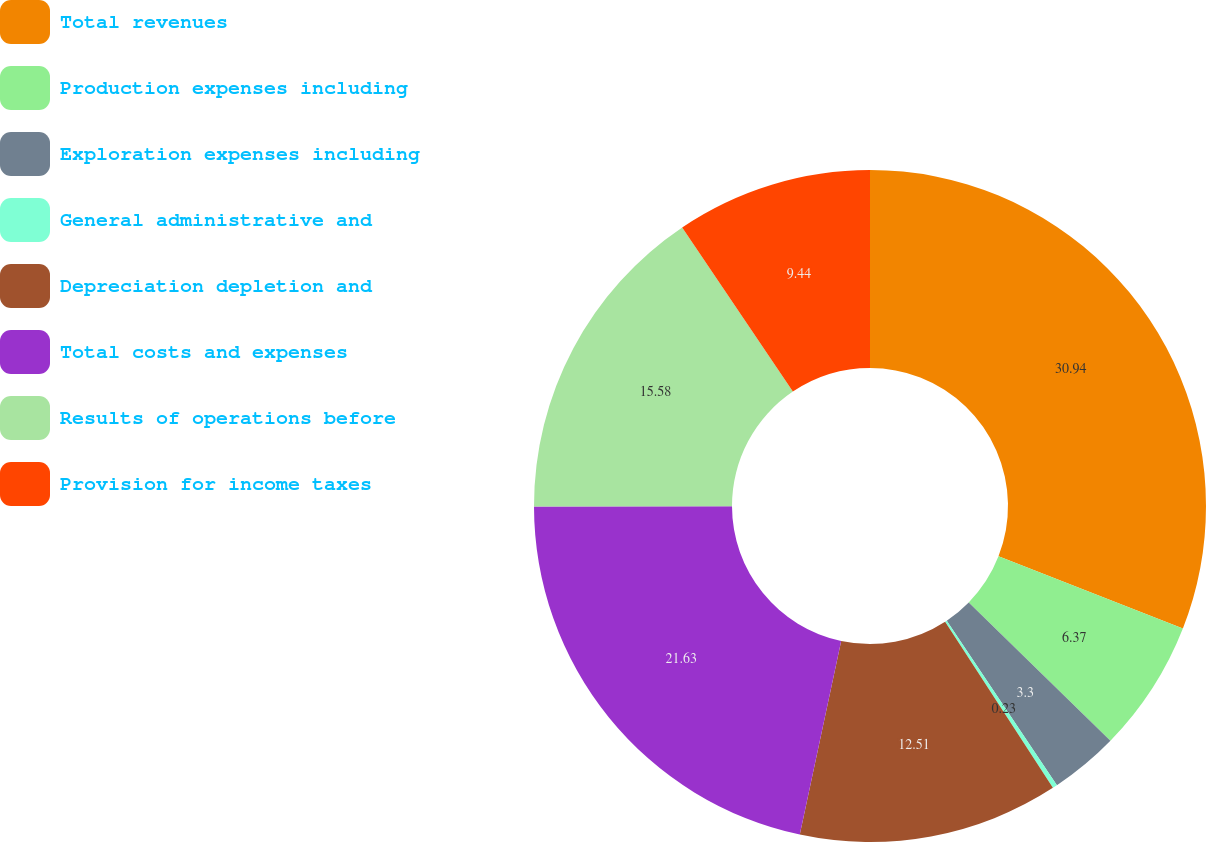Convert chart to OTSL. <chart><loc_0><loc_0><loc_500><loc_500><pie_chart><fcel>Total revenues<fcel>Production expenses including<fcel>Exploration expenses including<fcel>General administrative and<fcel>Depreciation depletion and<fcel>Total costs and expenses<fcel>Results of operations before<fcel>Provision for income taxes<nl><fcel>30.94%<fcel>6.37%<fcel>3.3%<fcel>0.23%<fcel>12.51%<fcel>21.63%<fcel>15.58%<fcel>9.44%<nl></chart> 